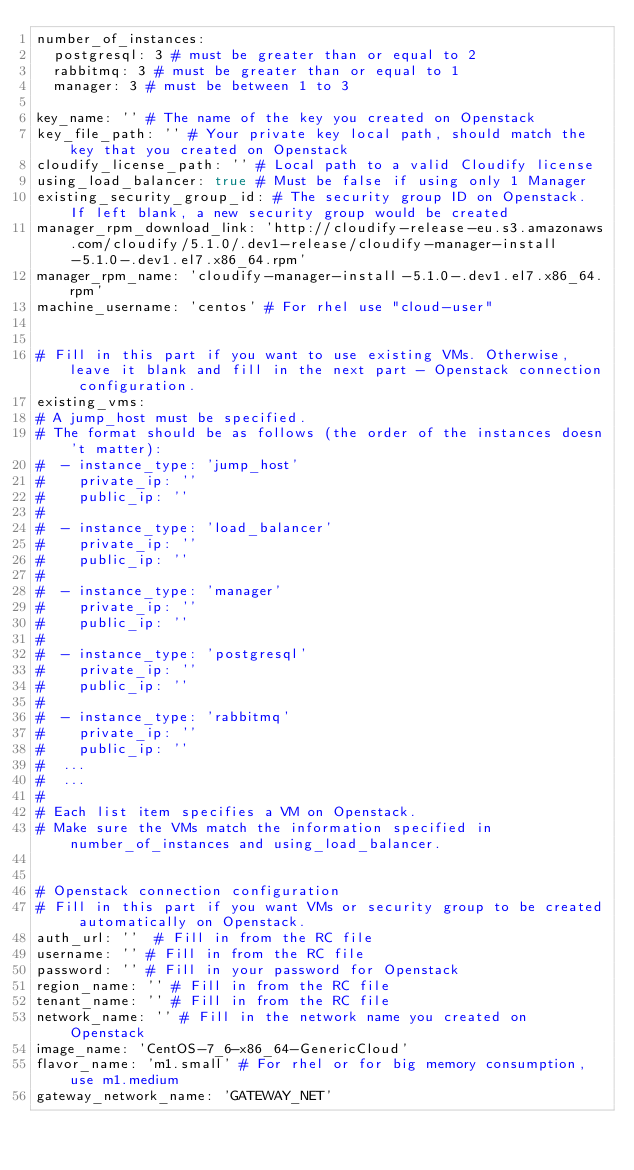Convert code to text. <code><loc_0><loc_0><loc_500><loc_500><_YAML_>number_of_instances:
  postgresql: 3 # must be greater than or equal to 2
  rabbitmq: 3 # must be greater than or equal to 1
  manager: 3 # must be between 1 to 3

key_name: '' # The name of the key you created on Openstack
key_file_path: '' # Your private key local path, should match the key that you created on Openstack
cloudify_license_path: '' # Local path to a valid Cloudify license
using_load_balancer: true # Must be false if using only 1 Manager
existing_security_group_id: # The security group ID on Openstack. If left blank, a new security group would be created
manager_rpm_download_link: 'http://cloudify-release-eu.s3.amazonaws.com/cloudify/5.1.0/.dev1-release/cloudify-manager-install-5.1.0-.dev1.el7.x86_64.rpm'
manager_rpm_name: 'cloudify-manager-install-5.1.0-.dev1.el7.x86_64.rpm'
machine_username: 'centos' # For rhel use "cloud-user"


# Fill in this part if you want to use existing VMs. Otherwise, leave it blank and fill in the next part - Openstack connection configuration.
existing_vms:
# A jump_host must be specified.
# The format should be as follows (the order of the instances doesn't matter):
#  - instance_type: 'jump_host'
#    private_ip: ''
#    public_ip: ''
#
#  - instance_type: 'load_balancer'
#    private_ip: ''
#    public_ip: ''
#
#  - instance_type: 'manager'
#    private_ip: ''
#    public_ip: ''
#
#  - instance_type: 'postgresql'
#    private_ip: ''
#    public_ip: ''
#
#  - instance_type: 'rabbitmq'
#    private_ip: ''
#    public_ip: ''
#  ...
#  ...
#
# Each list item specifies a VM on Openstack.
# Make sure the VMs match the information specified in number_of_instances and using_load_balancer.


# Openstack connection configuration
# Fill in this part if you want VMs or security group to be created automatically on Openstack.
auth_url: ''  # Fill in from the RC file
username: '' # Fill in from the RC file
password: '' # Fill in your password for Openstack
region_name: '' # Fill in from the RC file
tenant_name: '' # Fill in from the RC file
network_name: '' # Fill in the network name you created on Openstack
image_name: 'CentOS-7_6-x86_64-GenericCloud'
flavor_name: 'm1.small' # For rhel or for big memory consumption, use m1.medium
gateway_network_name: 'GATEWAY_NET'
</code> 